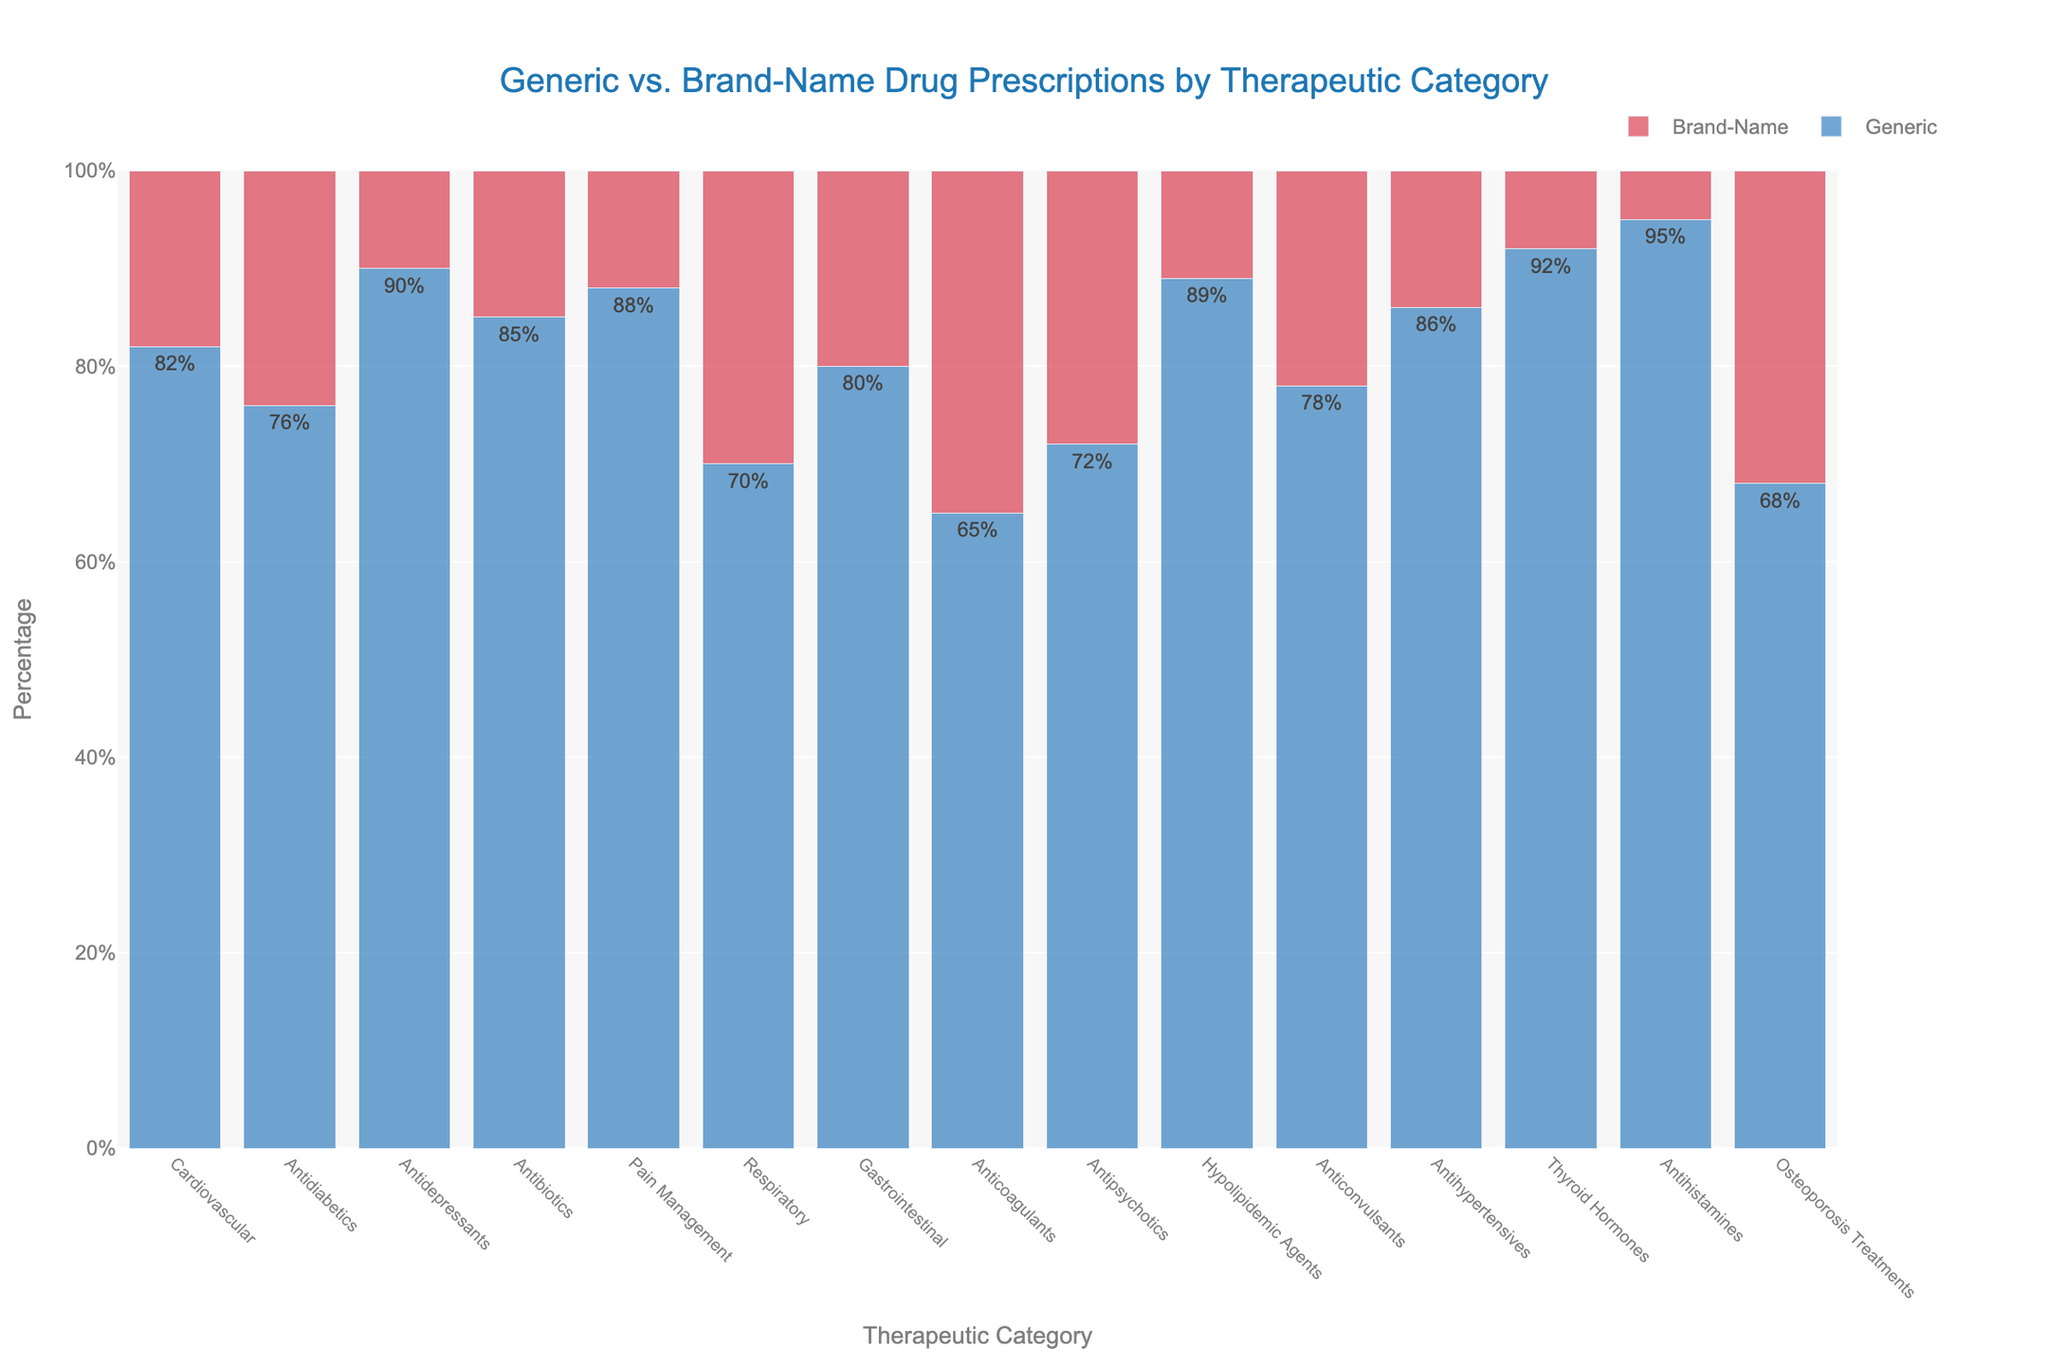What's the therapeutic category with the highest percentage of generic prescriptions? By observing the heights of the bars, the "Thyroid Hormones" category has the highest percentage of generic prescriptions at 92%.
Answer: Thyroid Hormones Which category has the smallest difference between the percentage of generic and brand-name prescriptions? The closest difference is observed in "Osteoporosis Treatments" where the difference between 68% (generic) and 32% (brand-name) is 36%.
Answer: Osteoporosis Treatments What's the average percentage of generic prescriptions across all therapeutic categories? To find the average, sum all the percentages of generic prescriptions and divide by the number of categories: (82 + 76 + 90 + 85 + 88 + 70 + 80 + 65 + 72 + 89 + 78 + 86 + 92 + 95 + 68) / 15 = 79.6%
Answer: 79.6% How many therapeutic categories have a higher percentage of generic prescriptions compared to brand-name prescriptions? By inspecting each pair of bars, all 15 therapeutic categories have a higher percentage of generic prescriptions as each blue bar (generic) is taller than the red bar (brand-name).
Answer: 15 Which category exhibits the greatest disparity between generic and brand-name prescriptions? "Antihistamines" shows the greatest disparity with 95% generic and 5% brand-name prescriptions, resulting in a 90% difference.
Answer: Antihistamines Are there any categories where brand-name prescriptions surpass generic prescriptions? By visually inspecting the bar heights, none of the categories have brand-name prescriptions surpassing generic prescriptions.
Answer: No Which category has the highest percentage of brand-name prescriptions? The "Osteoporosis Treatments" category has the highest percentage of brand-name prescriptions at 32%.
Answer: Osteoporosis Treatments Compare the percentages of generic prescriptions between "Antihyperlipidemic Agents" and "Antipsychotics". Which category has a greater percentage? "Hypolipidemic Agents" has a higher percentage of generic prescriptions (89%) compared to "Antipsychotics" (72%).
Answer: Hypolipidemic Agents What's the combined total percentage for generic prescriptions in "Cardiovascular" and "Antidiabetics" categories? Adding the percentages of generic prescriptions, 82% (Cardiovascular) + 76% (Antidiabetics) = 158%.
Answer: 158% How does the percentage of generic prescriptions in "Respiratory" compare to "Gastrointestinal"? "Respiratory" has 70% generic prescriptions, while "Gastrointestinal" has 80%. Thus, "Respiratory" is 10% lower.
Answer: 10% lower 